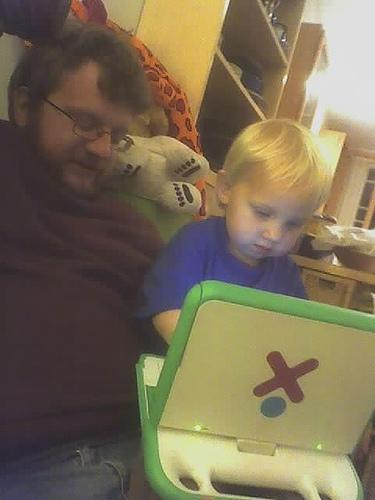What kind of action is the boy taking? Please explain your reasoning. typing. The action is typing. 